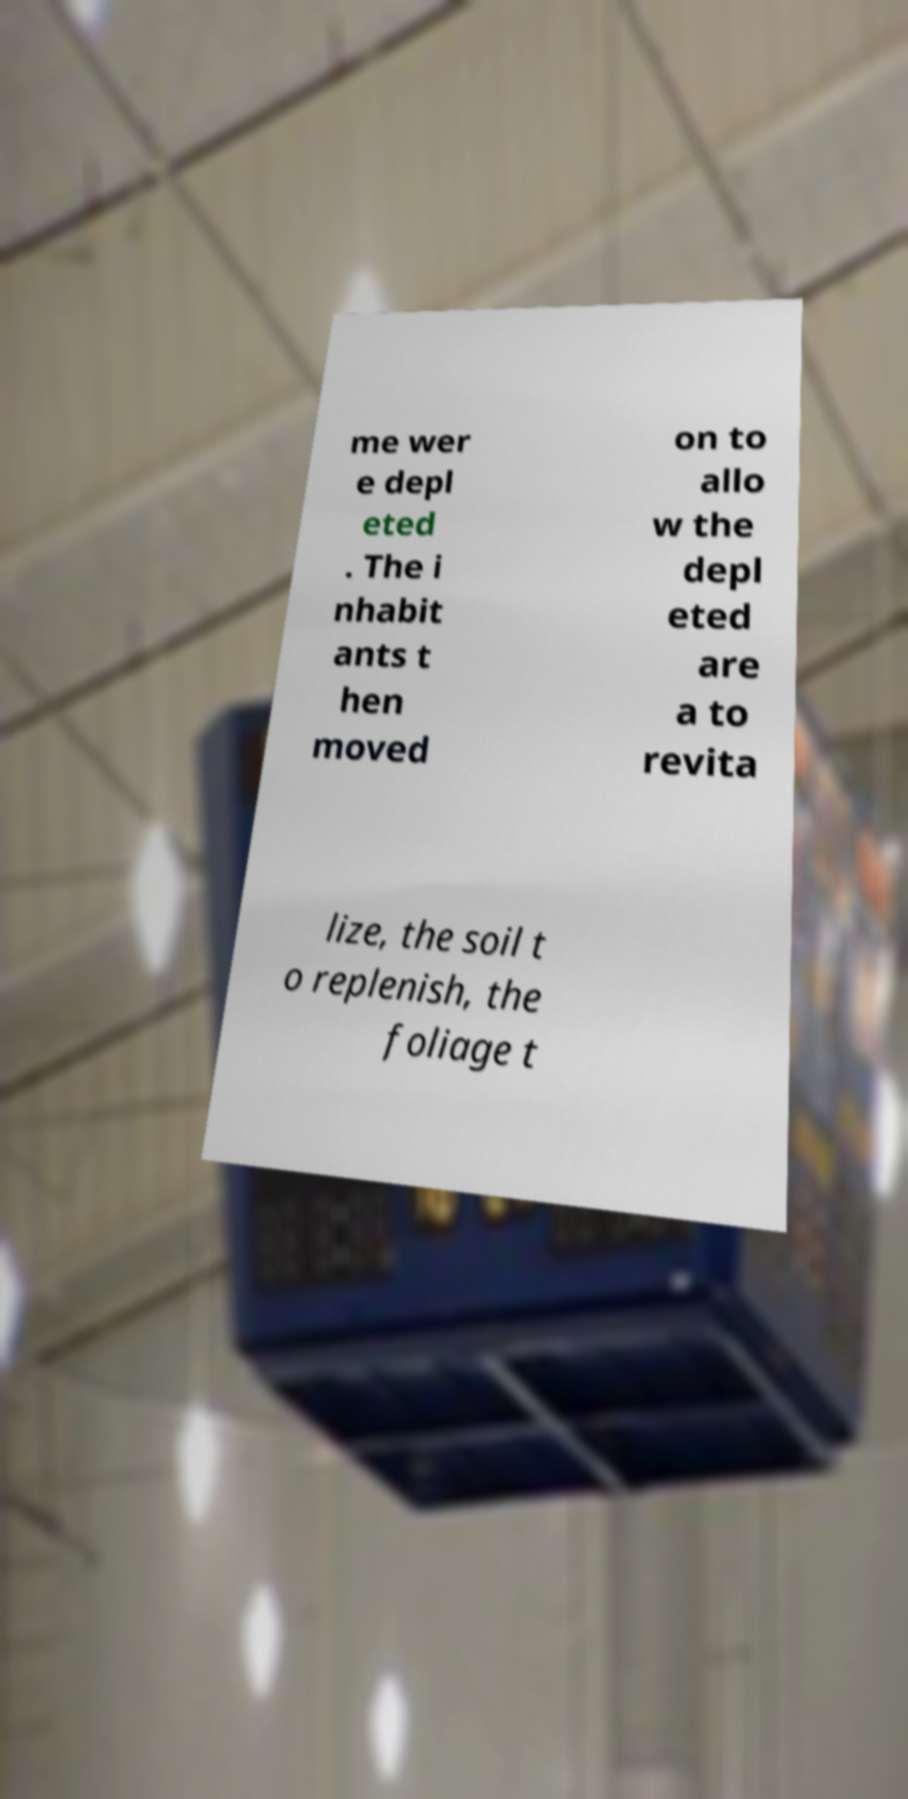What messages or text are displayed in this image? I need them in a readable, typed format. me wer e depl eted . The i nhabit ants t hen moved on to allo w the depl eted are a to revita lize, the soil t o replenish, the foliage t 